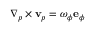Convert formula to latex. <formula><loc_0><loc_0><loc_500><loc_500>\nabla _ { p } \times { v } _ { p } = \omega _ { \phi } { e } _ { \phi }</formula> 